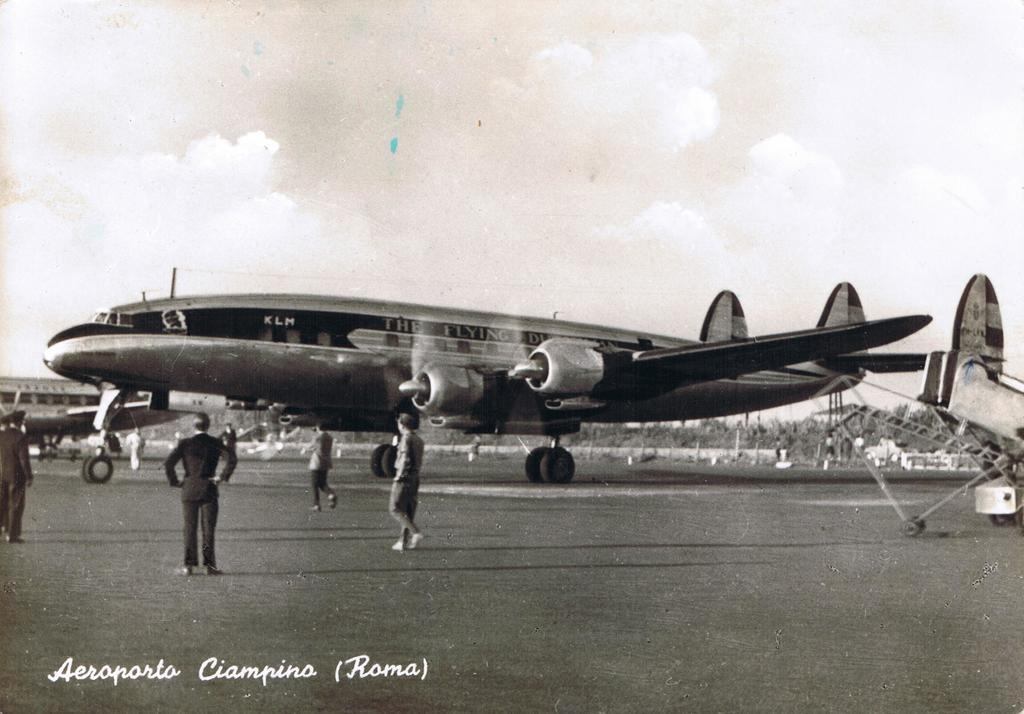<image>
Present a compact description of the photo's key features. An old airplane named after the Flying Dutchman 